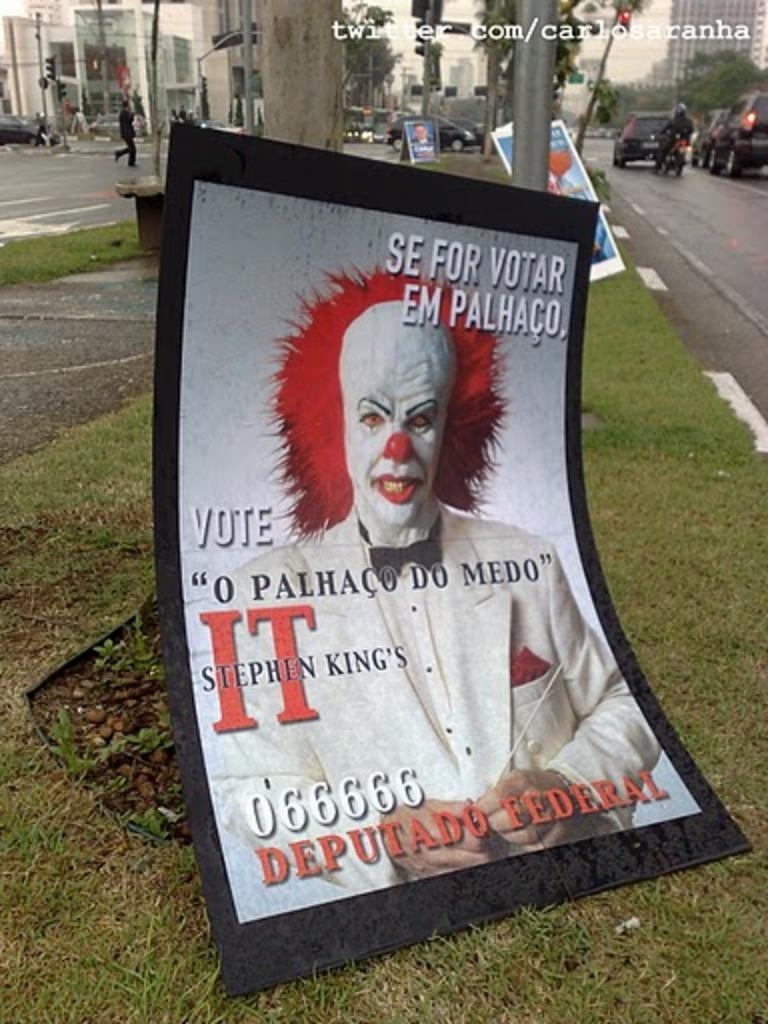<image>
Create a compact narrative representing the image presented. A poster with an IT character that says 06666 Deputado Federal 